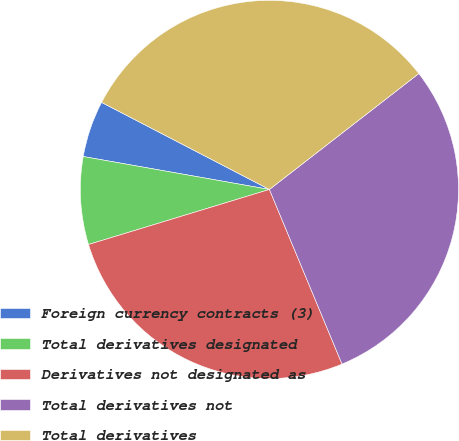<chart> <loc_0><loc_0><loc_500><loc_500><pie_chart><fcel>Foreign currency contracts (3)<fcel>Total derivatives designated<fcel>Derivatives not designated as<fcel>Total derivatives not<fcel>Total derivatives<nl><fcel>4.83%<fcel>7.49%<fcel>26.57%<fcel>29.23%<fcel>31.88%<nl></chart> 